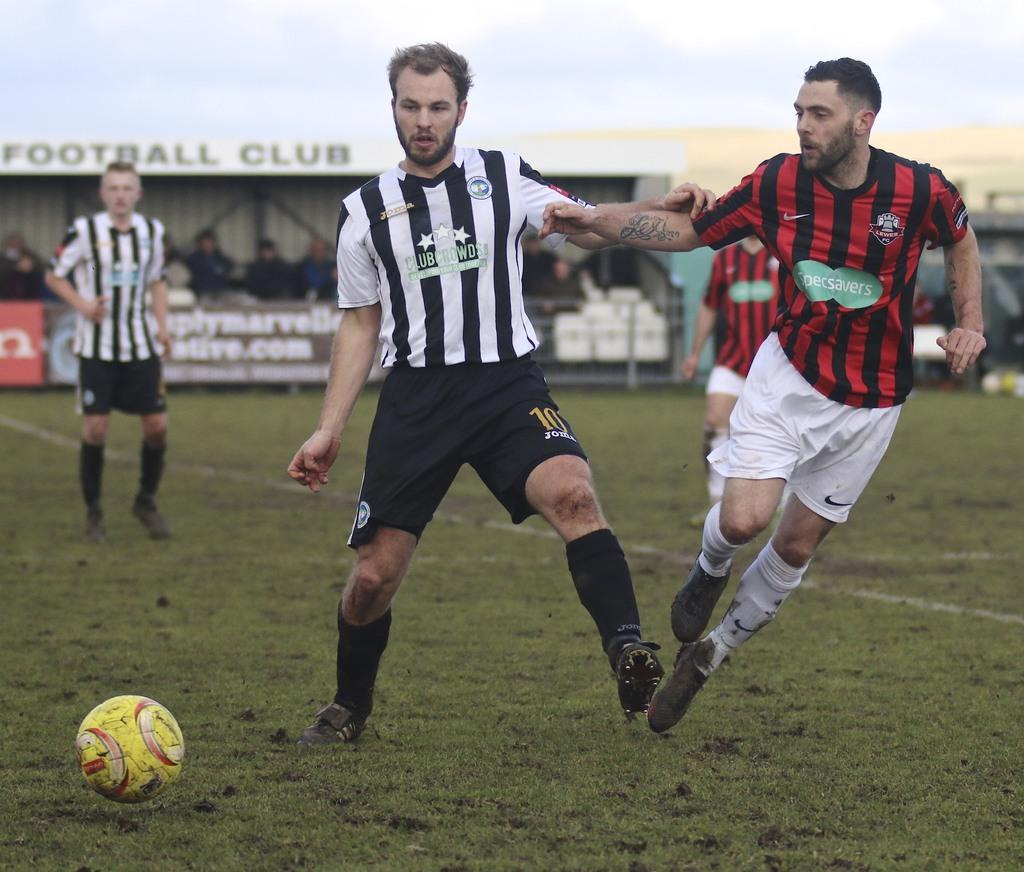<image>
Share a concise interpretation of the image provided. a couple players with one that has the word club on their jersey 